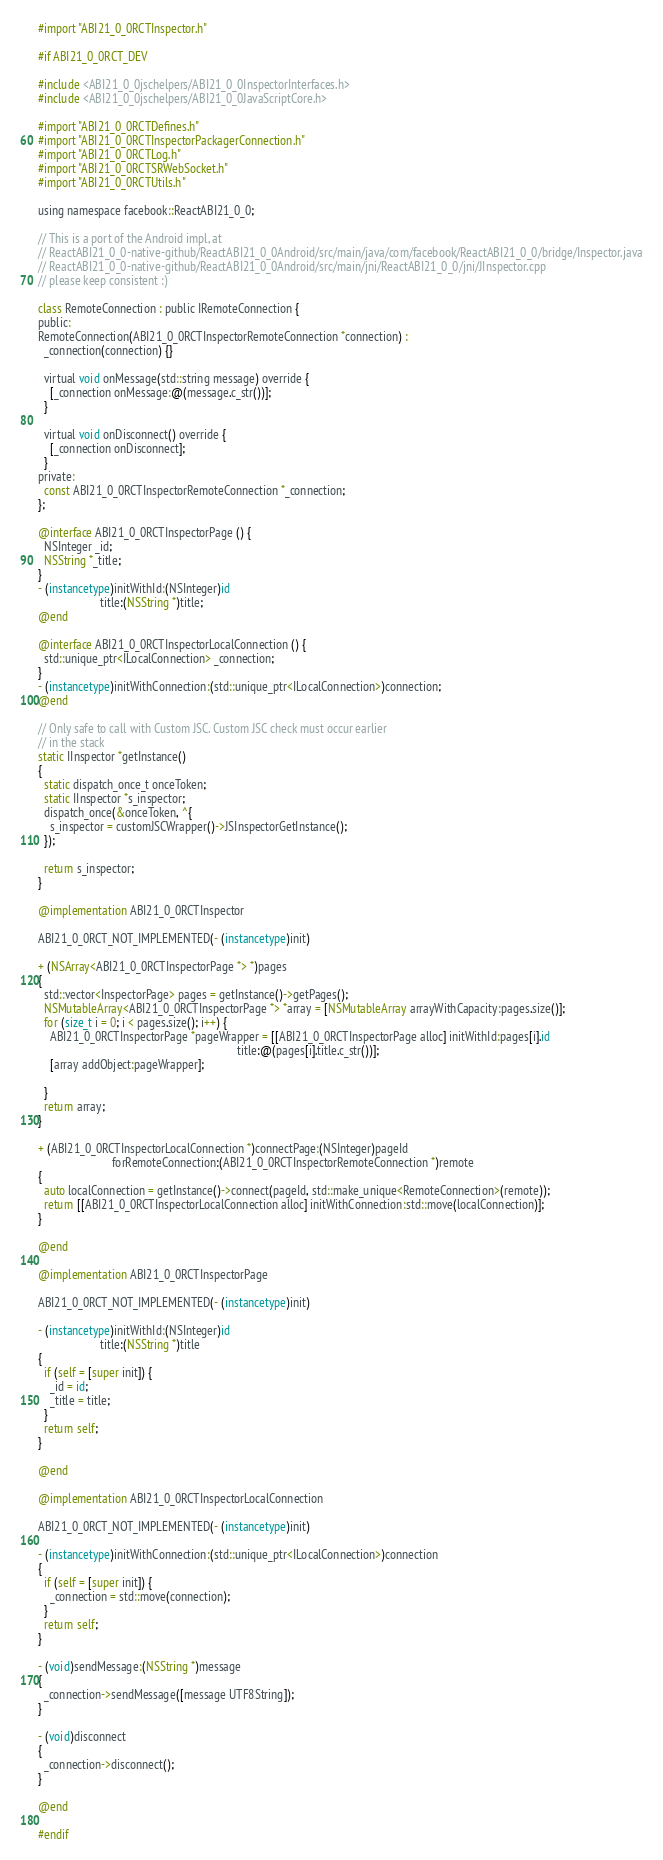Convert code to text. <code><loc_0><loc_0><loc_500><loc_500><_ObjectiveC_>
#import "ABI21_0_0RCTInspector.h"

#if ABI21_0_0RCT_DEV

#include <ABI21_0_0jschelpers/ABI21_0_0InspectorInterfaces.h>
#include <ABI21_0_0jschelpers/ABI21_0_0JavaScriptCore.h>

#import "ABI21_0_0RCTDefines.h"
#import "ABI21_0_0RCTInspectorPackagerConnection.h"
#import "ABI21_0_0RCTLog.h"
#import "ABI21_0_0RCTSRWebSocket.h"
#import "ABI21_0_0RCTUtils.h"

using namespace facebook::ReactABI21_0_0;

// This is a port of the Android impl, at
// ReactABI21_0_0-native-github/ReactABI21_0_0Android/src/main/java/com/facebook/ReactABI21_0_0/bridge/Inspector.java
// ReactABI21_0_0-native-github/ReactABI21_0_0Android/src/main/jni/ReactABI21_0_0/jni/JInspector.cpp
// please keep consistent :)

class RemoteConnection : public IRemoteConnection {
public:
RemoteConnection(ABI21_0_0RCTInspectorRemoteConnection *connection) :
  _connection(connection) {}

  virtual void onMessage(std::string message) override {
    [_connection onMessage:@(message.c_str())];
  }

  virtual void onDisconnect() override {
    [_connection onDisconnect];
  }
private:
  const ABI21_0_0RCTInspectorRemoteConnection *_connection;
};

@interface ABI21_0_0RCTInspectorPage () {
  NSInteger _id;
  NSString *_title;
}
- (instancetype)initWithId:(NSInteger)id
                     title:(NSString *)title;
@end

@interface ABI21_0_0RCTInspectorLocalConnection () {
  std::unique_ptr<ILocalConnection> _connection;
}
- (instancetype)initWithConnection:(std::unique_ptr<ILocalConnection>)connection;
@end

// Only safe to call with Custom JSC. Custom JSC check must occur earlier
// in the stack
static IInspector *getInstance()
{
  static dispatch_once_t onceToken;
  static IInspector *s_inspector;
  dispatch_once(&onceToken, ^{
    s_inspector = customJSCWrapper()->JSInspectorGetInstance();
  });

  return s_inspector;
}

@implementation ABI21_0_0RCTInspector

ABI21_0_0RCT_NOT_IMPLEMENTED(- (instancetype)init)

+ (NSArray<ABI21_0_0RCTInspectorPage *> *)pages
{
  std::vector<InspectorPage> pages = getInstance()->getPages();
  NSMutableArray<ABI21_0_0RCTInspectorPage *> *array = [NSMutableArray arrayWithCapacity:pages.size()];
  for (size_t i = 0; i < pages.size(); i++) {
    ABI21_0_0RCTInspectorPage *pageWrapper = [[ABI21_0_0RCTInspectorPage alloc] initWithId:pages[i].id
                                                                   title:@(pages[i].title.c_str())];
    [array addObject:pageWrapper];

  }
  return array;
}

+ (ABI21_0_0RCTInspectorLocalConnection *)connectPage:(NSInteger)pageId
                         forRemoteConnection:(ABI21_0_0RCTInspectorRemoteConnection *)remote
{
  auto localConnection = getInstance()->connect(pageId, std::make_unique<RemoteConnection>(remote));
  return [[ABI21_0_0RCTInspectorLocalConnection alloc] initWithConnection:std::move(localConnection)];
}

@end

@implementation ABI21_0_0RCTInspectorPage

ABI21_0_0RCT_NOT_IMPLEMENTED(- (instancetype)init)

- (instancetype)initWithId:(NSInteger)id
                     title:(NSString *)title
{
  if (self = [super init]) {
    _id = id;
    _title = title;
  }
  return self;
}

@end

@implementation ABI21_0_0RCTInspectorLocalConnection

ABI21_0_0RCT_NOT_IMPLEMENTED(- (instancetype)init)

- (instancetype)initWithConnection:(std::unique_ptr<ILocalConnection>)connection
{
  if (self = [super init]) {
    _connection = std::move(connection);
  }
  return self;
}

- (void)sendMessage:(NSString *)message
{
  _connection->sendMessage([message UTF8String]);
}

- (void)disconnect
{
  _connection->disconnect();
}

@end

#endif
</code> 